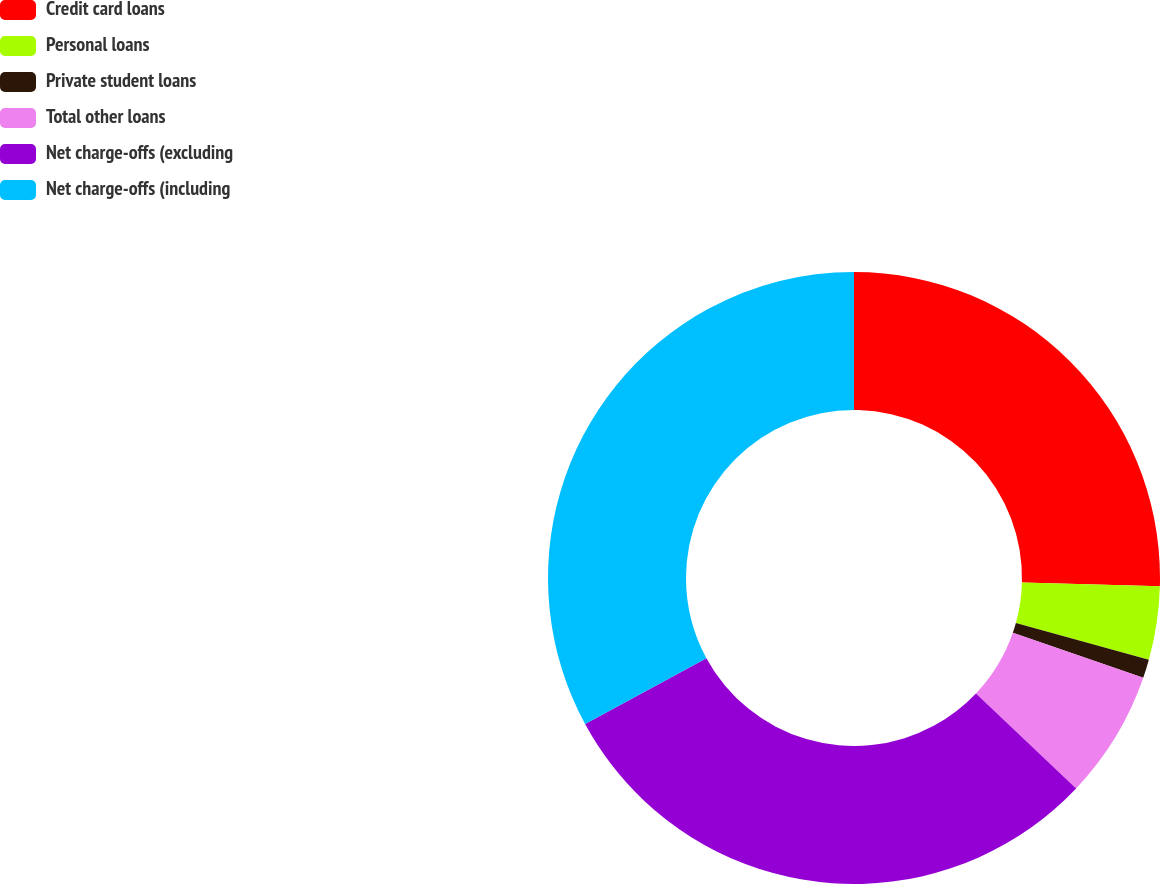Convert chart to OTSL. <chart><loc_0><loc_0><loc_500><loc_500><pie_chart><fcel>Credit card loans<fcel>Personal loans<fcel>Private student loans<fcel>Total other loans<fcel>Net charge-offs (excluding<fcel>Net charge-offs (including<nl><fcel>25.43%<fcel>3.88%<fcel>0.98%<fcel>6.78%<fcel>30.01%<fcel>32.92%<nl></chart> 